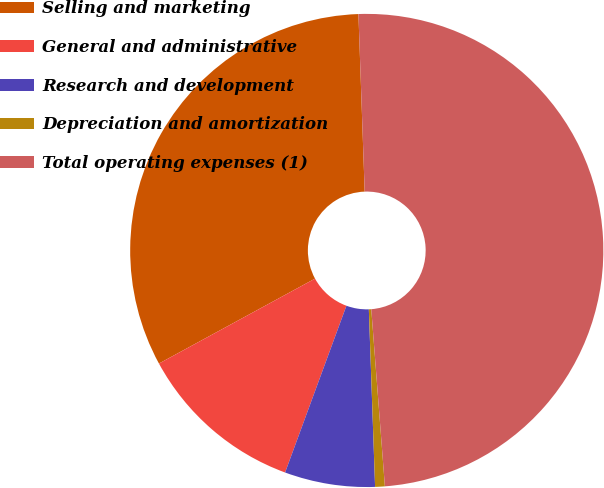<chart> <loc_0><loc_0><loc_500><loc_500><pie_chart><fcel>Selling and marketing<fcel>General and administrative<fcel>Research and development<fcel>Depreciation and amortization<fcel>Total operating expenses (1)<nl><fcel>32.37%<fcel>11.46%<fcel>6.17%<fcel>0.66%<fcel>49.34%<nl></chart> 